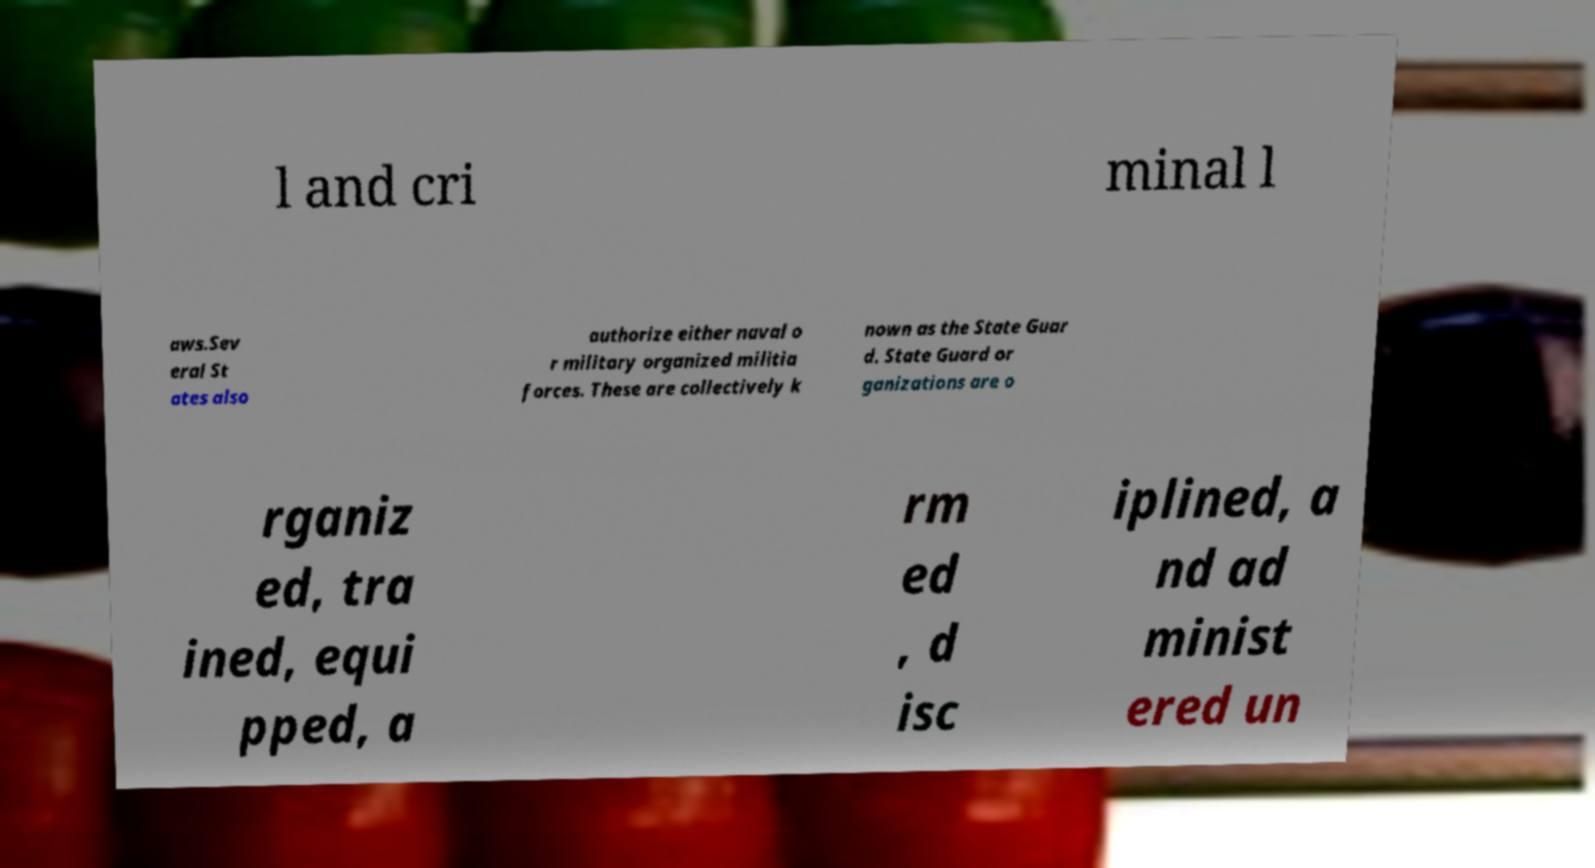Could you extract and type out the text from this image? l and cri minal l aws.Sev eral St ates also authorize either naval o r military organized militia forces. These are collectively k nown as the State Guar d. State Guard or ganizations are o rganiz ed, tra ined, equi pped, a rm ed , d isc iplined, a nd ad minist ered un 